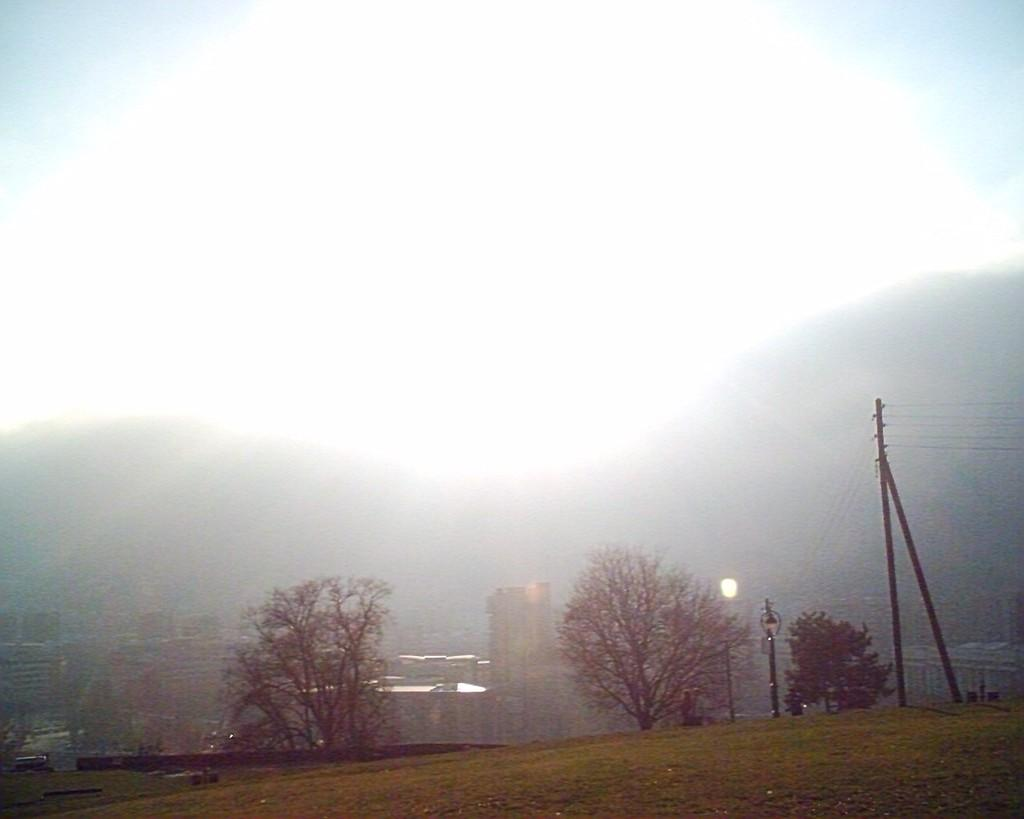What type of vegetation is present on the ground in the image? There are trees on the grass floor in the image. What can be seen in the distance behind the trees? There are buildings and hills visible in the background of the image. What part of the natural environment is visible in the image? The sky is visible in the image. How many geese are grazing on the plantation in the image? There is no plantation or geese present in the image. What type of sponge is being used to clean the trees in the image? There is no sponge or cleaning activity depicted in the image. 